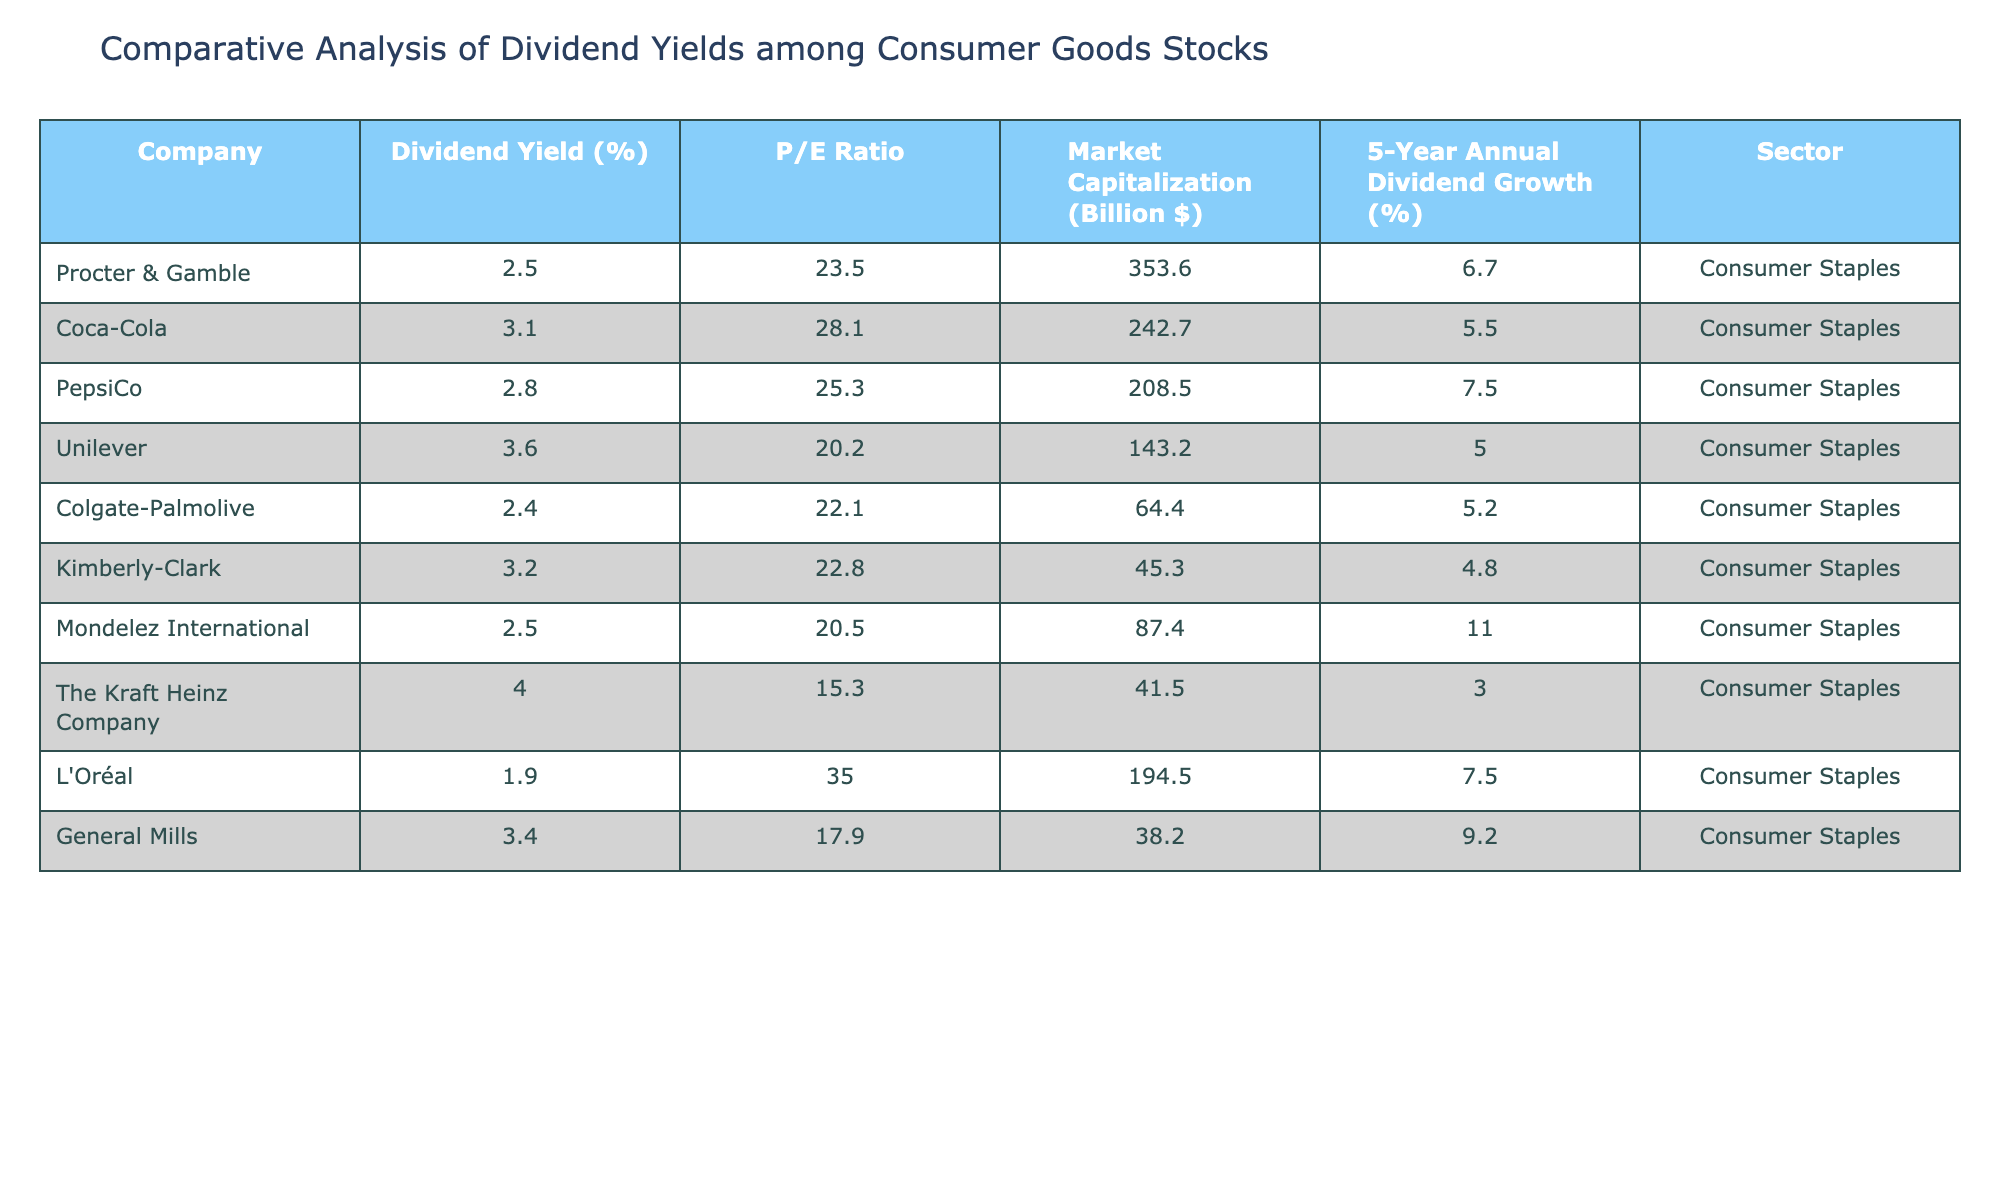What is the company with the highest dividend yield? By examining the "Dividend Yield (%)" column, we can see that The Kraft Heinz Company has the highest value at 4.00% among the listed companies.
Answer: The Kraft Heinz Company What is the average P/E ratio of the companies listed? To find the average P/E ratio, we sum all the P/E ratios (23.5 + 28.1 + 25.3 + 20.2 + 22.1 + 22.8 + 20.5 + 15.3 + 35.0 + 17.9) =  220.7, and since there are 10 companies, we divide by 10. Thus, the average P/E ratio is 220.7 / 10 = 22.07.
Answer: 22.07 Is the dividend yield of Colgate-Palmolive higher than that of Mondelez International? Colgate-Palmolive has a dividend yield of 2.40%, while Mondelez International has a dividend yield of 2.50%. Since 2.40% is less than 2.50%, the statement is false.
Answer: No How many companies have a dividend yield above 3%? Looking through the "Dividend Yield (%)" column, we find that Coca-Cola (3.10%), PepsiCo (2.80%), Unilever (3.60%), Kimberly-Clark (3.20%), and General Mills (3.40%) all have dividend yields above 3%. This totals to 4 companies.
Answer: 4 What is the difference in market capitalization between Procter & Gamble and Colgate-Palmolive? Procter & Gamble has a market capitalization of 353.6 billion dollars, while Colgate-Palmolive has 64.4 billion dollars. To find the difference, we subtract: 353.6 - 64.4 = 289.2 billion dollars.
Answer: 289.2 Billion $ What is the median dividend yield of the companies listed? First, we list the dividend yields in ascending order: 1.90, 2.40, 2.50, 2.50, 2.80, 3.10, 3.20, 3.40, 3.60, 4.00. Since there are 10 values, the median will be the average of the 5th and 6th values: (2.80 + 3.10)/2 = 2.95.
Answer: 2.95 Is the 5-year annual dividend growth of Coca-Cola greater than that of Unilever? Coca-Cola has a 5-Year Annual Dividend Growth of 5.5%, while Unilever's is 5%. Since 5.5% is greater than 5%, the statement is true.
Answer: Yes Which company has the lowest market capitalization? By examining the "Market Capitalization (Billion $)" column, we find that Kimberly-Clark has the lowest market capitalization at 45.3 billion dollars compared to the others.
Answer: Kimberly-Clark 